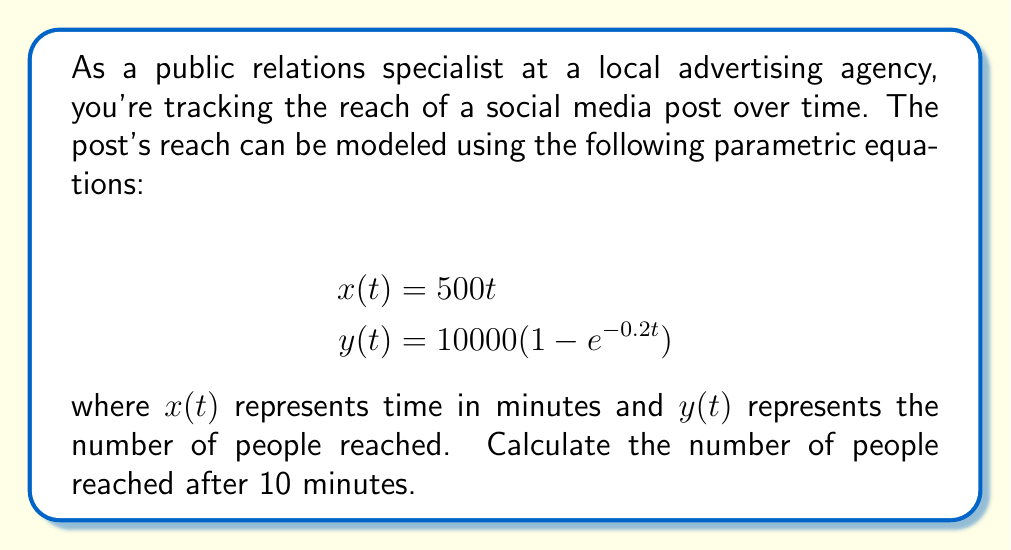Provide a solution to this math problem. To solve this problem, we need to follow these steps:

1. Understand the given parametric equations:
   $x(t) = 500t$ represents time in minutes
   $y(t) = 10000(1 - e^{-0.2t})$ represents the number of people reached

2. We want to find $y(t)$ when $x(t) = 10$ minutes. First, we need to find the value of $t$ when $x(t) = 10$:

   $$10 = 500t$$
   $$t = \frac{10}{500} = 0.02$$

3. Now that we know $t = 0.02$, we can substitute this value into the equation for $y(t)$:

   $$y(0.02) = 10000(1 - e^{-0.2(0.02)})$$

4. Simplify the expression inside the parentheses:
   $$y(0.02) = 10000(1 - e^{-0.004})$$

5. Use a calculator or computer to evaluate $e^{-0.004}$:
   $$e^{-0.004} \approx 0.996$$

6. Subtract this value from 1:
   $$1 - 0.996 = 0.004$$

7. Multiply by 10000:
   $$10000 * 0.004 = 40$$

Therefore, after 10 minutes, the social media post will have reached approximately 40 people.
Answer: The number of people reached after 10 minutes is approximately 40. 